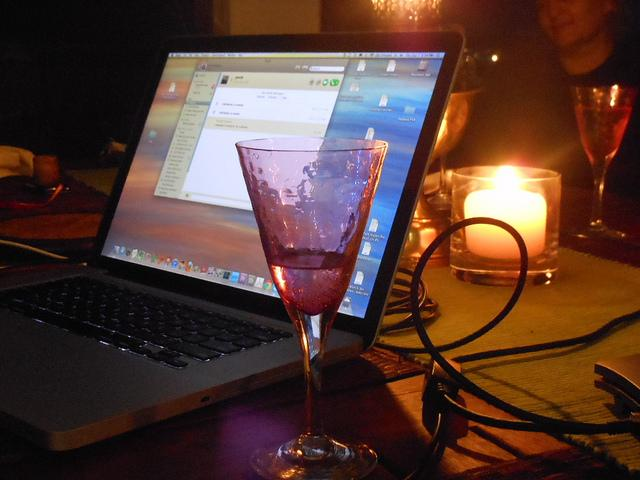What country most frequently uses wine glasses this shape?

Choices:
A) japan
B) china
C) usa
D) france france 